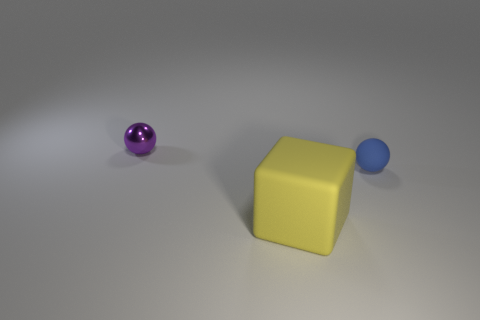Add 3 large purple matte objects. How many objects exist? 6 Subtract all spheres. How many objects are left? 1 Subtract 0 red cylinders. How many objects are left? 3 Subtract all brown metallic balls. Subtract all large matte cubes. How many objects are left? 2 Add 3 large yellow cubes. How many large yellow cubes are left? 4 Add 1 large cubes. How many large cubes exist? 2 